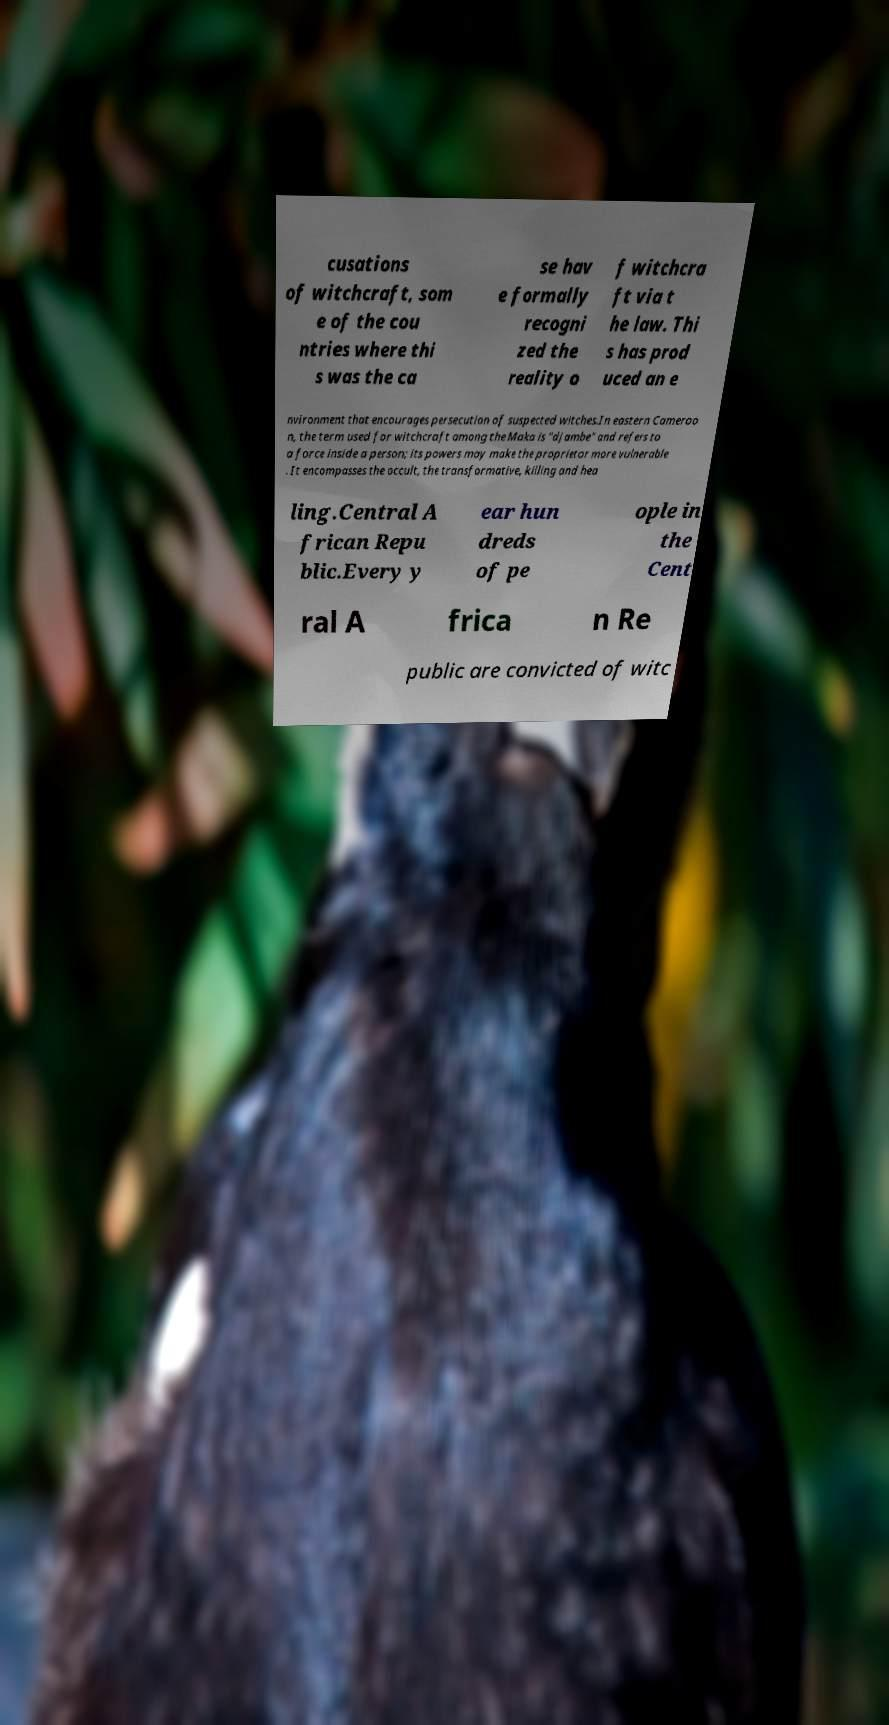Can you read and provide the text displayed in the image?This photo seems to have some interesting text. Can you extract and type it out for me? cusations of witchcraft, som e of the cou ntries where thi s was the ca se hav e formally recogni zed the reality o f witchcra ft via t he law. Thi s has prod uced an e nvironment that encourages persecution of suspected witches.In eastern Cameroo n, the term used for witchcraft among the Maka is "djambe" and refers to a force inside a person; its powers may make the proprietor more vulnerable . It encompasses the occult, the transformative, killing and hea ling.Central A frican Repu blic.Every y ear hun dreds of pe ople in the Cent ral A frica n Re public are convicted of witc 